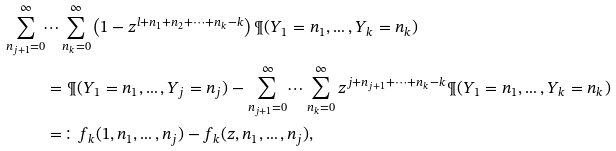<formula> <loc_0><loc_0><loc_500><loc_500>\sum _ { n _ { j + 1 } = 0 } ^ { \infty } & \dots \sum _ { n _ { k } = 0 } ^ { \infty } \left ( 1 - z ^ { l + n _ { 1 } + n _ { 2 } + \dots + n _ { k } - k } \right ) \P ( Y _ { 1 } = n _ { 1 } , \dots , Y _ { k } = n _ { k } ) \\ & = \P ( Y _ { 1 } = n _ { 1 } , \dots , Y _ { j } = n _ { j } ) - \sum _ { n _ { j + 1 } = 0 } ^ { \infty } \dots \sum _ { n _ { k } = 0 } ^ { \infty } z ^ { j + n _ { j + 1 } + \dots + n _ { k } - k } \P ( Y _ { 1 } = n _ { 1 } , \dots , Y _ { k } = n _ { k } ) \\ & = \colon f _ { k } ( 1 , n _ { 1 } , \dots , n _ { j } ) - f _ { k } ( z , n _ { 1 } , \dots , n _ { j } ) ,</formula> 